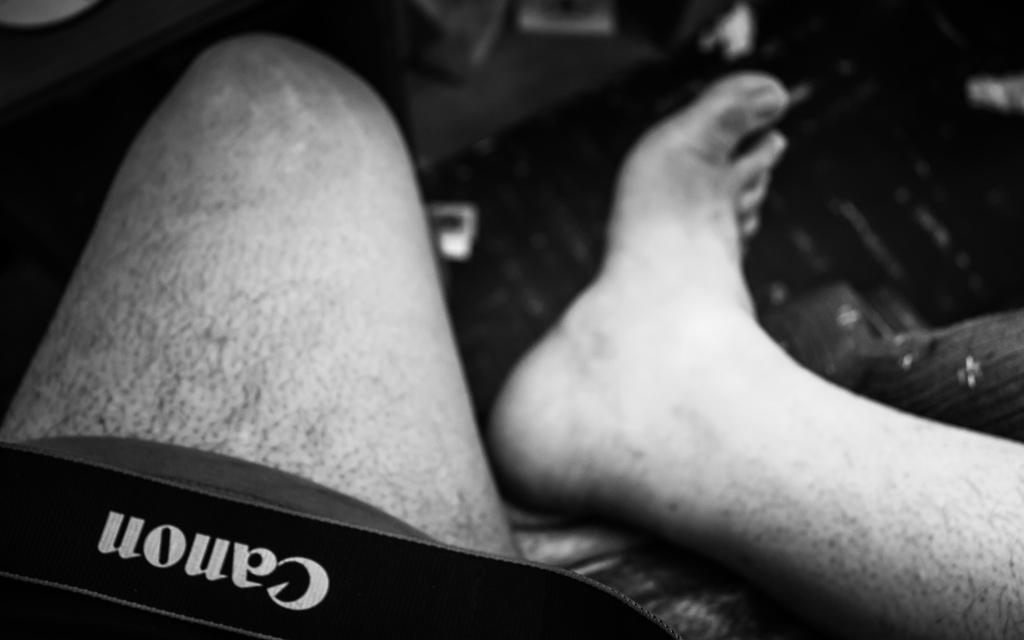What can be seen in the image that belongs to people? There are legs of persons in the image. Can you describe the black object in the bottom left of the image? There is a black object with a cannon on it in the bottom left of the image. What type of sink can be seen in the image? There is no sink present in the image. Is there any indication of winter in the image? The image does not provide any information about the season, so it cannot be determined if it is winter. 